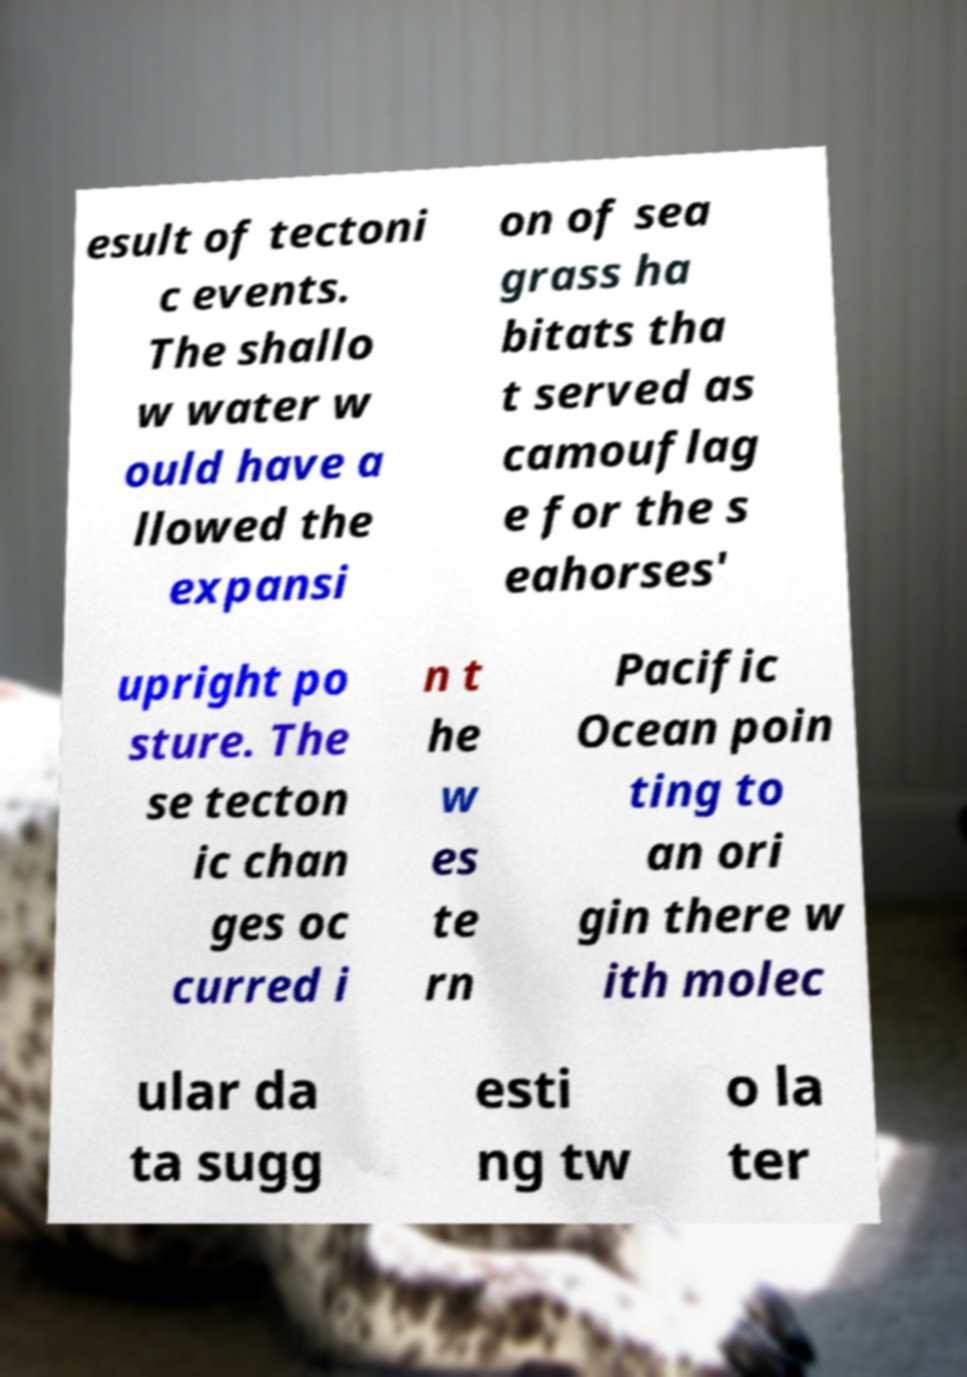For documentation purposes, I need the text within this image transcribed. Could you provide that? esult of tectoni c events. The shallo w water w ould have a llowed the expansi on of sea grass ha bitats tha t served as camouflag e for the s eahorses' upright po sture. The se tecton ic chan ges oc curred i n t he w es te rn Pacific Ocean poin ting to an ori gin there w ith molec ular da ta sugg esti ng tw o la ter 